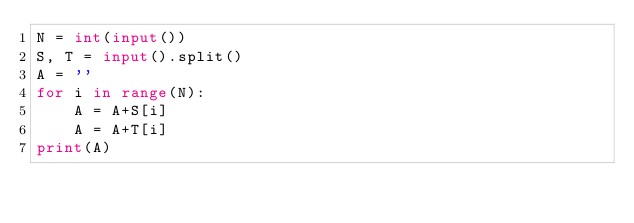Convert code to text. <code><loc_0><loc_0><loc_500><loc_500><_Python_>N = int(input())
S, T = input().split()
A = ''
for i in range(N):
    A = A+S[i]
    A = A+T[i]
print(A)</code> 